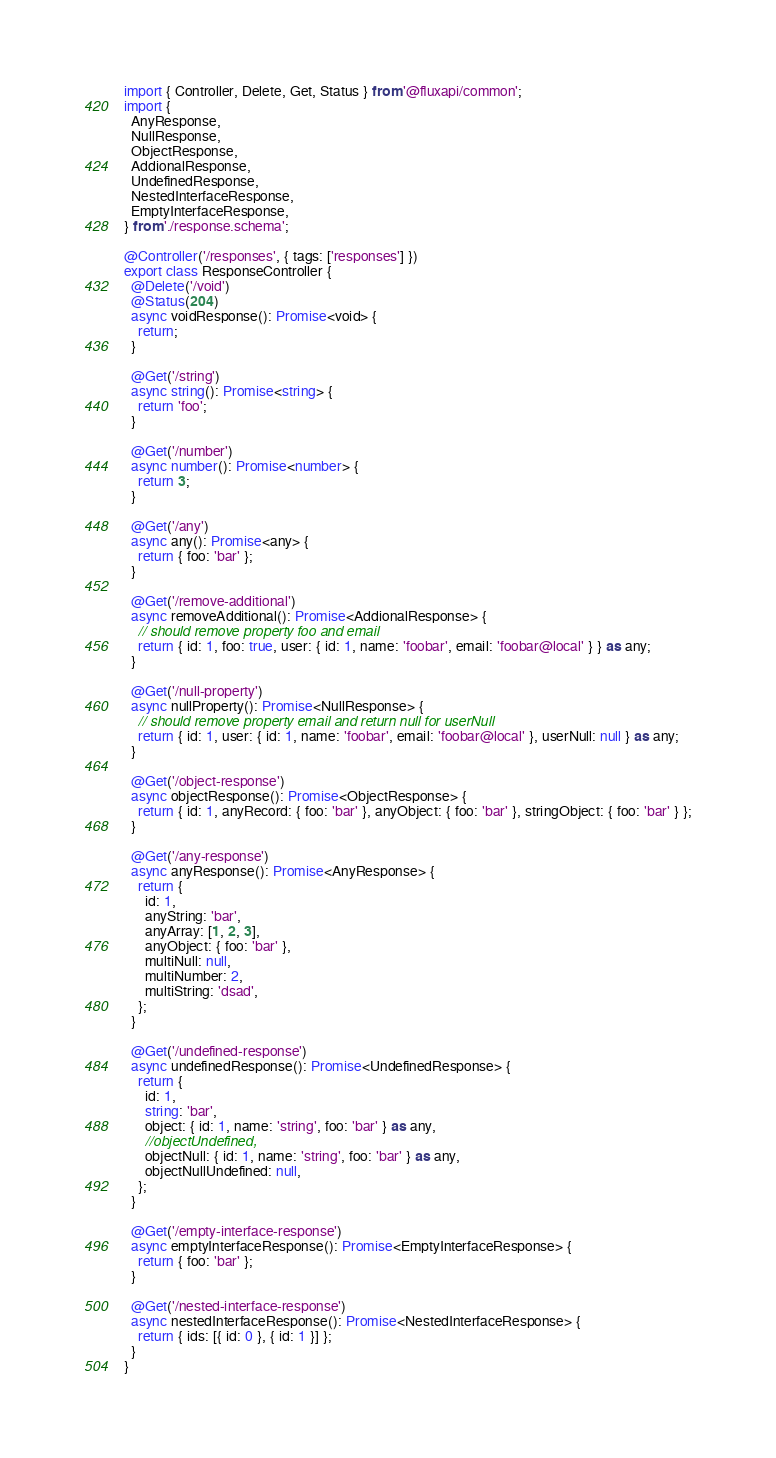<code> <loc_0><loc_0><loc_500><loc_500><_TypeScript_>import { Controller, Delete, Get, Status } from '@fluxapi/common';
import {
  AnyResponse,
  NullResponse,
  ObjectResponse,
  AddionalResponse,
  UndefinedResponse,
  NestedInterfaceResponse,
  EmptyInterfaceResponse,
} from './response.schema';

@Controller('/responses', { tags: ['responses'] })
export class ResponseController {
  @Delete('/void')
  @Status(204)
  async voidResponse(): Promise<void> {
    return;
  }

  @Get('/string')
  async string(): Promise<string> {
    return 'foo';
  }

  @Get('/number')
  async number(): Promise<number> {
    return 3;
  }

  @Get('/any')
  async any(): Promise<any> {
    return { foo: 'bar' };
  }

  @Get('/remove-additional')
  async removeAdditional(): Promise<AddionalResponse> {
    // should remove property foo and email
    return { id: 1, foo: true, user: { id: 1, name: 'foobar', email: 'foobar@local' } } as any;
  }

  @Get('/null-property')
  async nullProperty(): Promise<NullResponse> {
    // should remove property email and return null for userNull
    return { id: 1, user: { id: 1, name: 'foobar', email: 'foobar@local' }, userNull: null } as any;
  }

  @Get('/object-response')
  async objectResponse(): Promise<ObjectResponse> {
    return { id: 1, anyRecord: { foo: 'bar' }, anyObject: { foo: 'bar' }, stringObject: { foo: 'bar' } };
  }

  @Get('/any-response')
  async anyResponse(): Promise<AnyResponse> {
    return {
      id: 1,
      anyString: 'bar',
      anyArray: [1, 2, 3],
      anyObject: { foo: 'bar' },
      multiNull: null,
      multiNumber: 2,
      multiString: 'dsad',
    };
  }

  @Get('/undefined-response')
  async undefinedResponse(): Promise<UndefinedResponse> {
    return {
      id: 1,
      string: 'bar',
      object: { id: 1, name: 'string', foo: 'bar' } as any,
      //objectUndefined,
      objectNull: { id: 1, name: 'string', foo: 'bar' } as any,
      objectNullUndefined: null,
    };
  }

  @Get('/empty-interface-response')
  async emptyInterfaceResponse(): Promise<EmptyInterfaceResponse> {
    return { foo: 'bar' };
  }

  @Get('/nested-interface-response')
  async nestedInterfaceResponse(): Promise<NestedInterfaceResponse> {
    return { ids: [{ id: 0 }, { id: 1 }] };
  }
}
</code> 